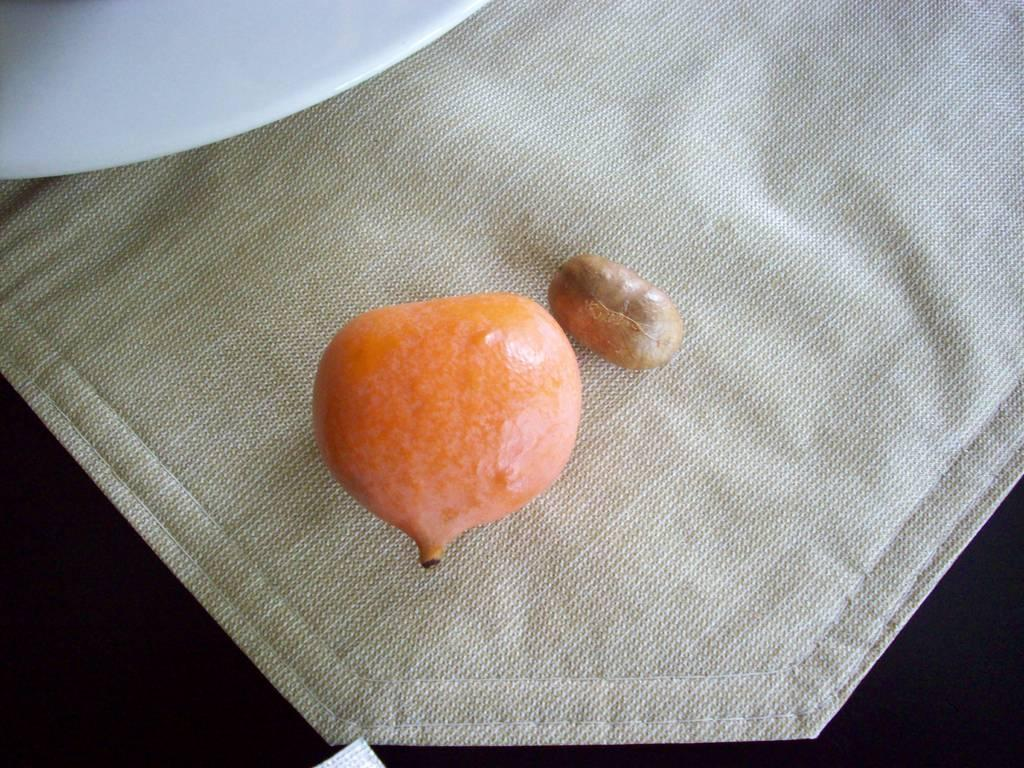What type of food is present in the image? There is a fruit in the image. What part of the fruit is also visible in the image? There is a seed in the image. Where are the fruit and seed placed? The fruit and seed are on a napkin. On what surface is the napkin resting? The napkin is on a table. What other item is near the fruit on the table? There is a plate beside the fruit. What type of agreement is being discussed by the stranger in the image? There is no stranger present in the image, and therefore no discussion of any agreement. 